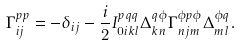<formula> <loc_0><loc_0><loc_500><loc_500>\Gamma _ { i j } ^ { p p } = - \delta _ { i j } - \frac { i } { 2 } I _ { 0 i k l } ^ { p q q } \Delta _ { k n } ^ { q \phi } \Gamma _ { n j m } ^ { \phi p \phi } \Delta _ { m l } ^ { \phi q } .</formula> 